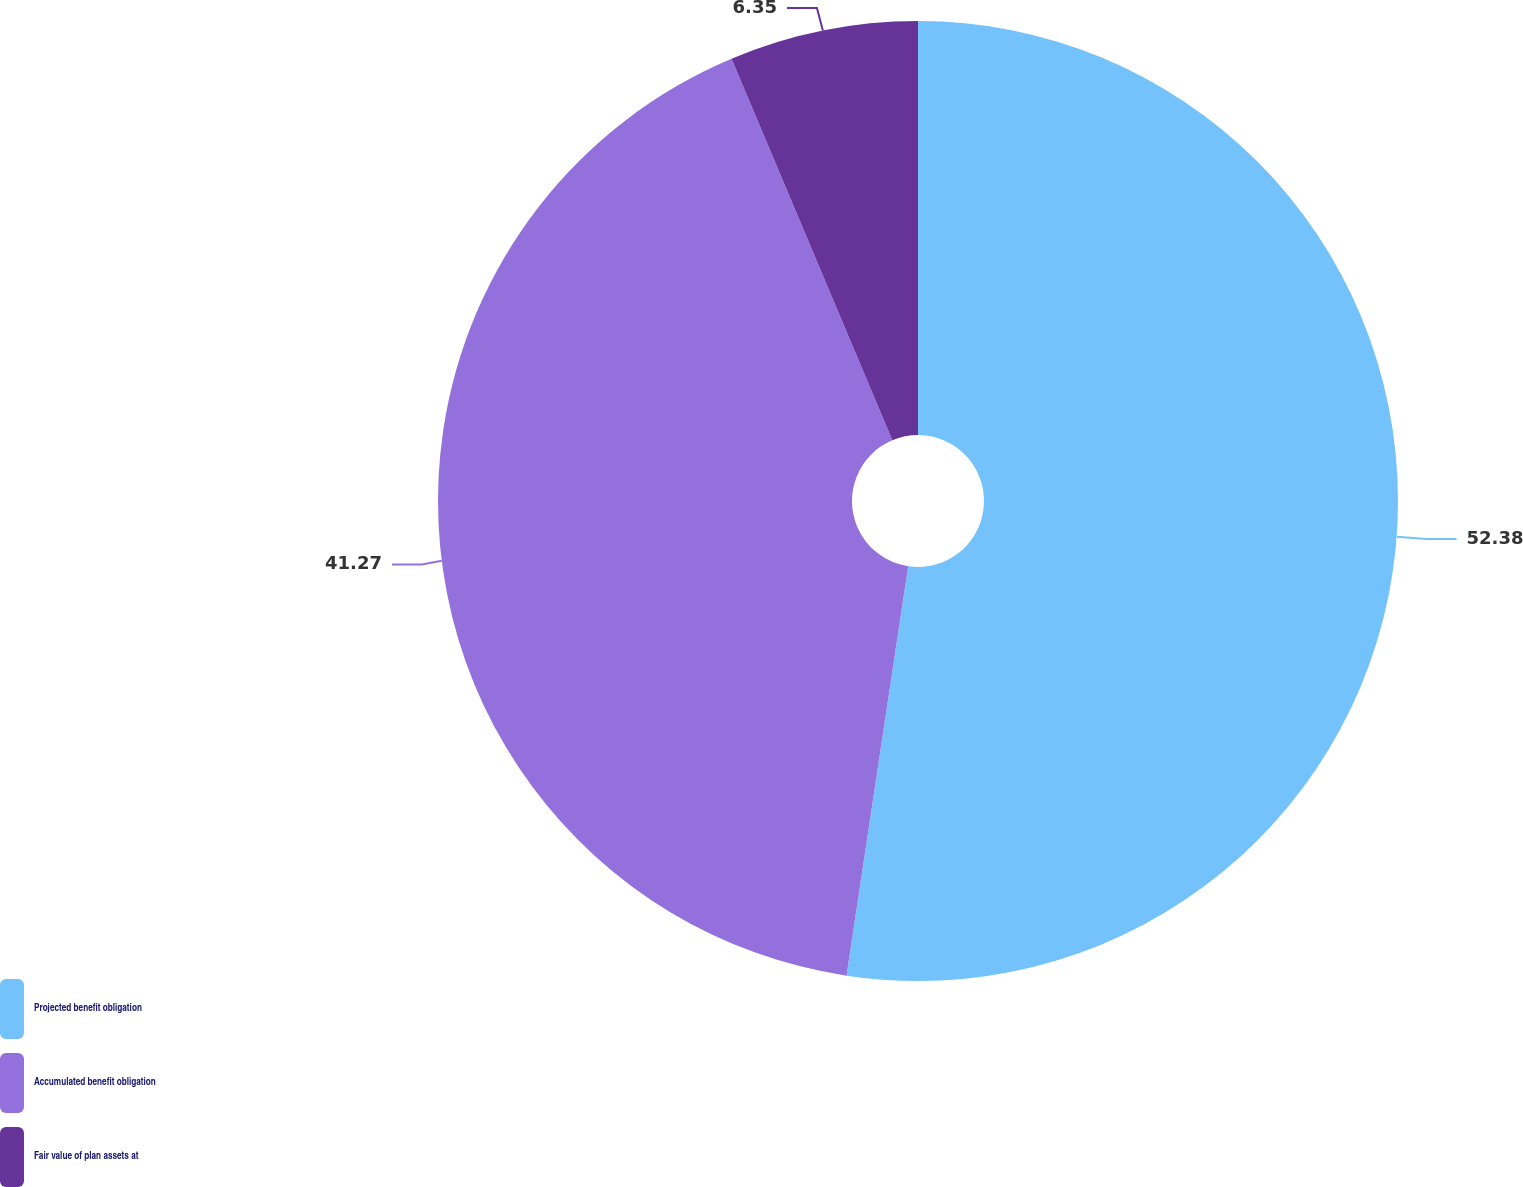Convert chart to OTSL. <chart><loc_0><loc_0><loc_500><loc_500><pie_chart><fcel>Projected benefit obligation<fcel>Accumulated benefit obligation<fcel>Fair value of plan assets at<nl><fcel>52.38%<fcel>41.27%<fcel>6.35%<nl></chart> 